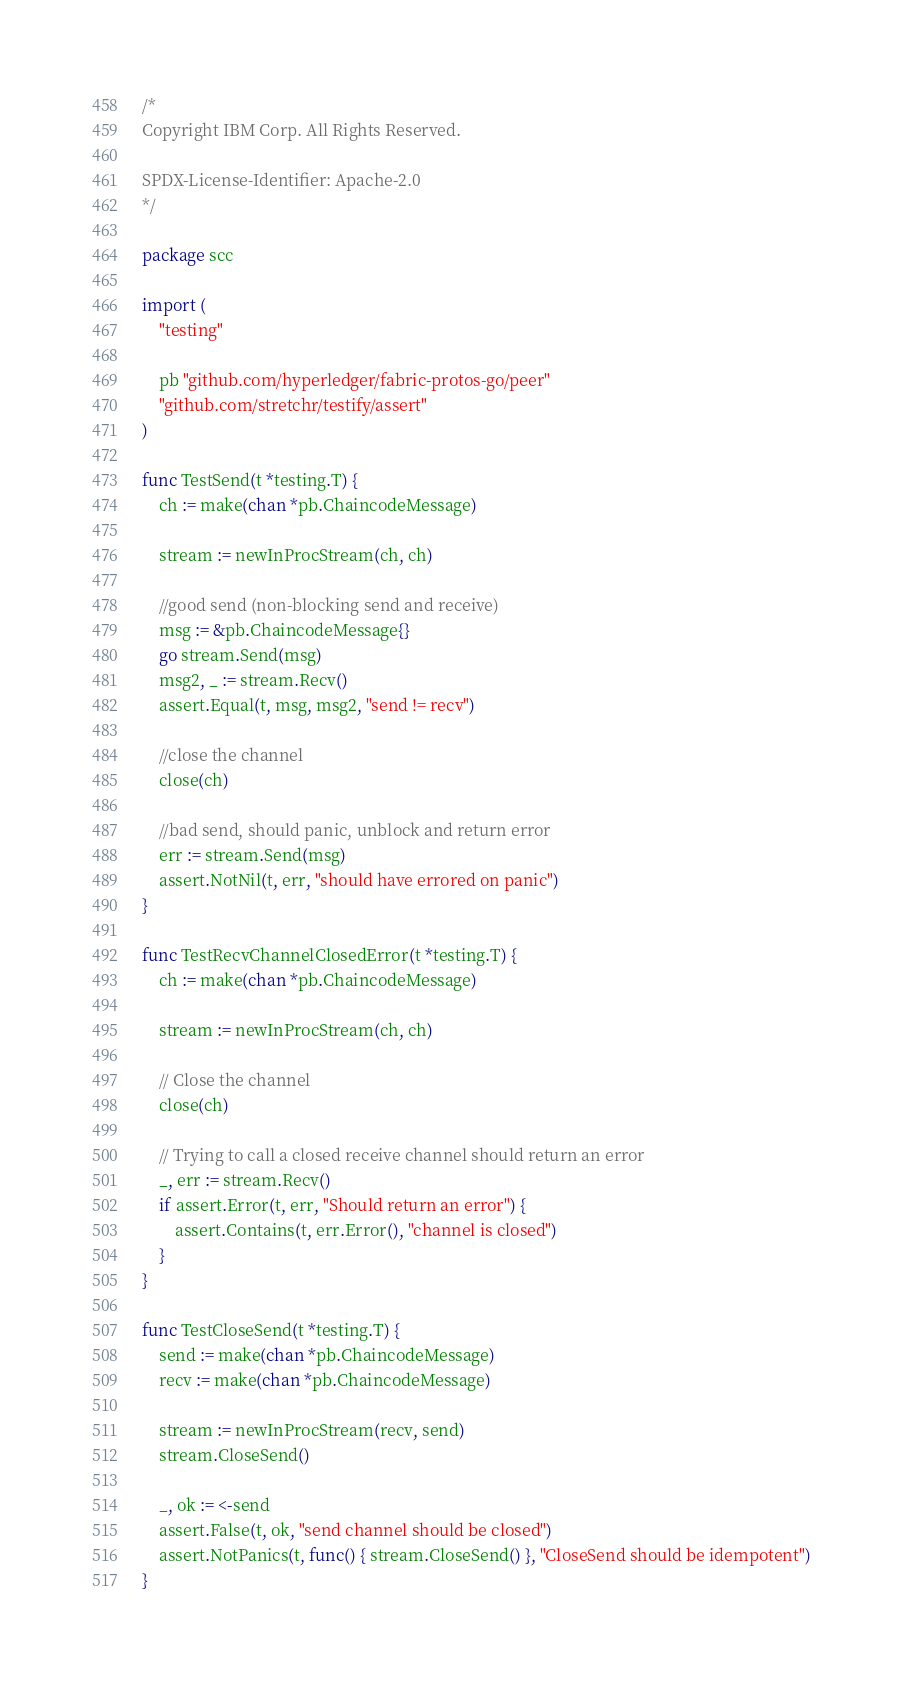<code> <loc_0><loc_0><loc_500><loc_500><_Go_>/*
Copyright IBM Corp. All Rights Reserved.

SPDX-License-Identifier: Apache-2.0
*/

package scc

import (
	"testing"

	pb "github.com/hyperledger/fabric-protos-go/peer"
	"github.com/stretchr/testify/assert"
)

func TestSend(t *testing.T) {
	ch := make(chan *pb.ChaincodeMessage)

	stream := newInProcStream(ch, ch)

	//good send (non-blocking send and receive)
	msg := &pb.ChaincodeMessage{}
	go stream.Send(msg)
	msg2, _ := stream.Recv()
	assert.Equal(t, msg, msg2, "send != recv")

	//close the channel
	close(ch)

	//bad send, should panic, unblock and return error
	err := stream.Send(msg)
	assert.NotNil(t, err, "should have errored on panic")
}

func TestRecvChannelClosedError(t *testing.T) {
	ch := make(chan *pb.ChaincodeMessage)

	stream := newInProcStream(ch, ch)

	// Close the channel
	close(ch)

	// Trying to call a closed receive channel should return an error
	_, err := stream.Recv()
	if assert.Error(t, err, "Should return an error") {
		assert.Contains(t, err.Error(), "channel is closed")
	}
}

func TestCloseSend(t *testing.T) {
	send := make(chan *pb.ChaincodeMessage)
	recv := make(chan *pb.ChaincodeMessage)

	stream := newInProcStream(recv, send)
	stream.CloseSend()

	_, ok := <-send
	assert.False(t, ok, "send channel should be closed")
	assert.NotPanics(t, func() { stream.CloseSend() }, "CloseSend should be idempotent")
}
</code> 